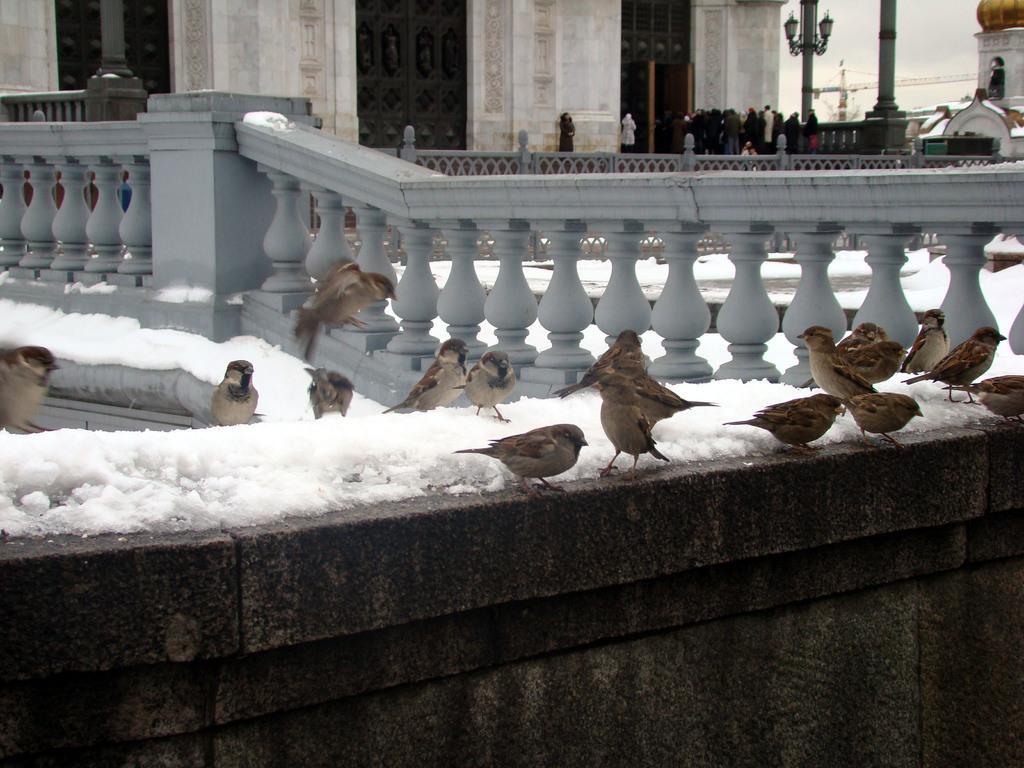Please provide a concise description of this image. In this image I can see few birds which are brown, black and cream in color are standing on the concrete wall. I can see some snow on the wall. In the background I can see number of people are standing, the grey colored railing, few poles, a bridge to the right top of the image, a building and the sky. 